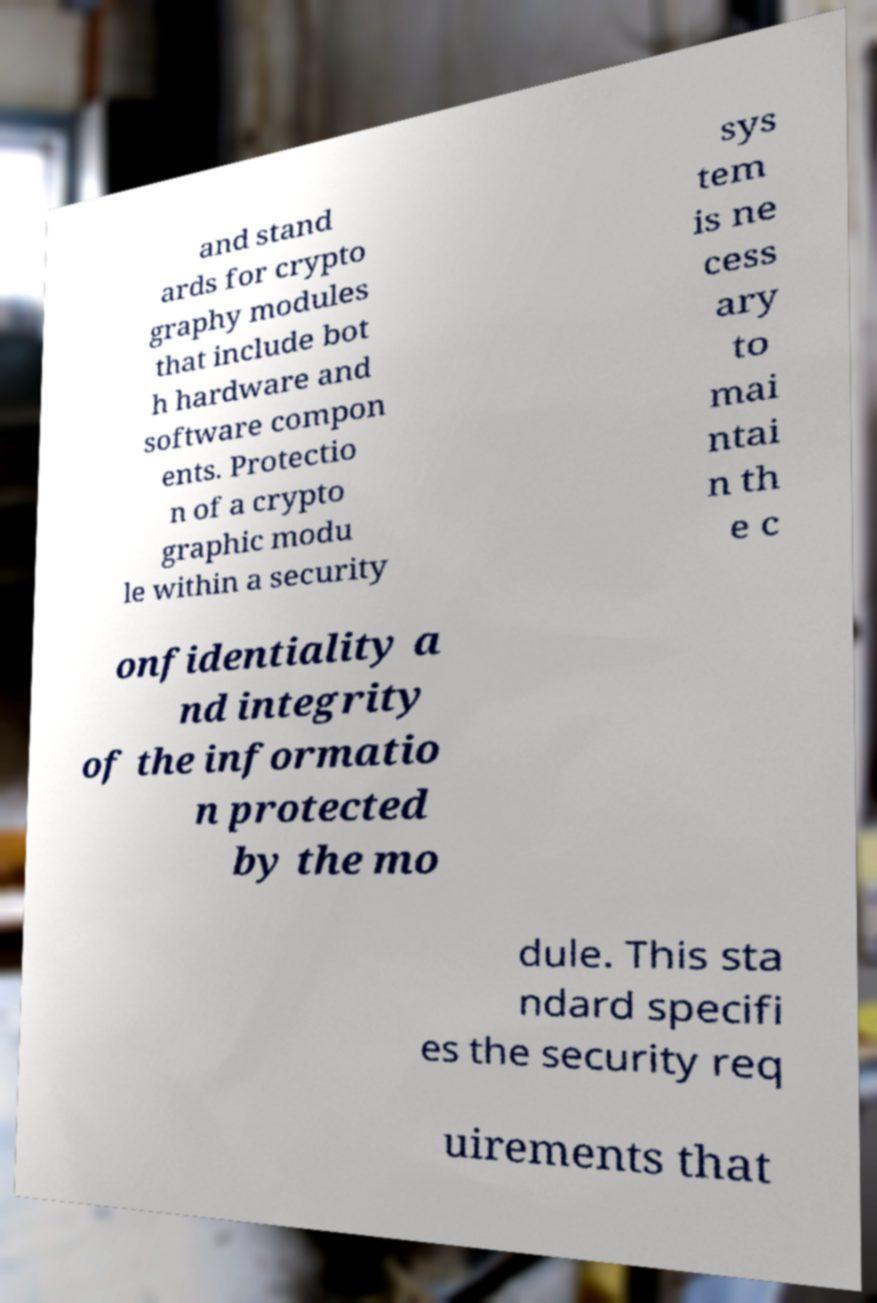For documentation purposes, I need the text within this image transcribed. Could you provide that? and stand ards for crypto graphy modules that include bot h hardware and software compon ents. Protectio n of a crypto graphic modu le within a security sys tem is ne cess ary to mai ntai n th e c onfidentiality a nd integrity of the informatio n protected by the mo dule. This sta ndard specifi es the security req uirements that 